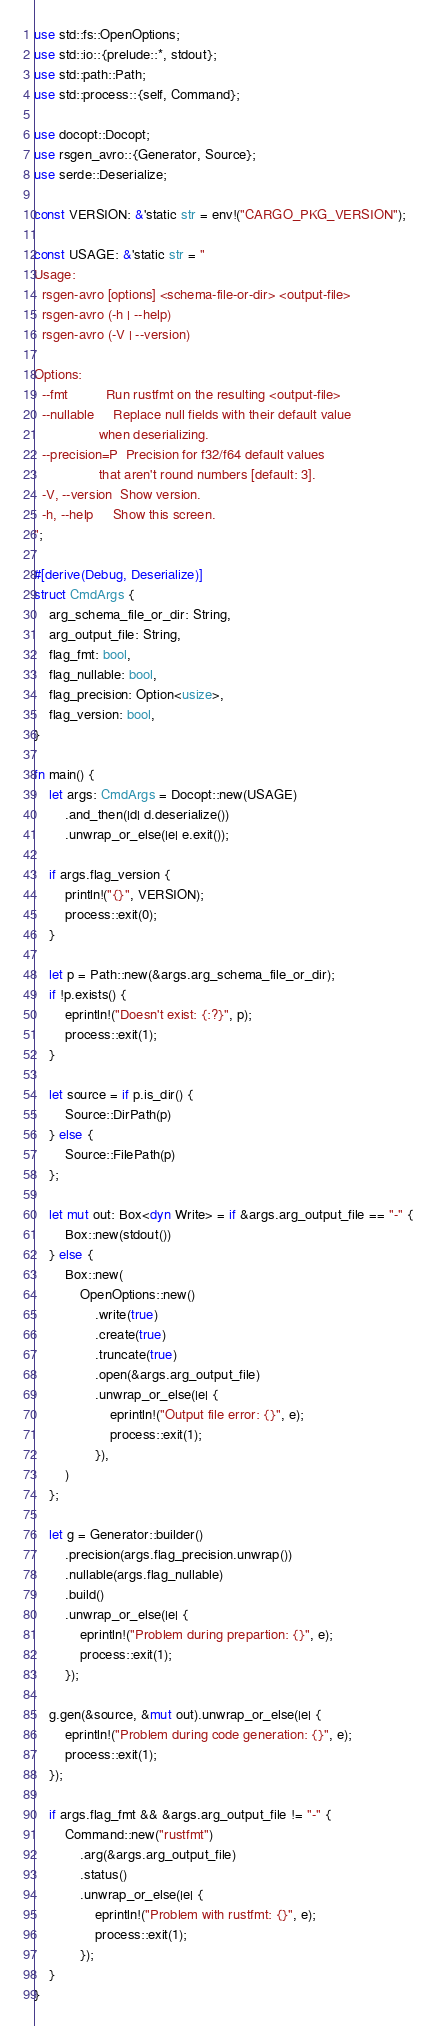<code> <loc_0><loc_0><loc_500><loc_500><_Rust_>use std::fs::OpenOptions;
use std::io::{prelude::*, stdout};
use std::path::Path;
use std::process::{self, Command};

use docopt::Docopt;
use rsgen_avro::{Generator, Source};
use serde::Deserialize;

const VERSION: &'static str = env!("CARGO_PKG_VERSION");

const USAGE: &'static str = "
Usage:
  rsgen-avro [options] <schema-file-or-dir> <output-file>
  rsgen-avro (-h | --help)
  rsgen-avro (-V | --version)

Options:
  --fmt          Run rustfmt on the resulting <output-file>
  --nullable     Replace null fields with their default value
                 when deserializing.
  --precision=P  Precision for f32/f64 default values
                 that aren't round numbers [default: 3].
  -V, --version  Show version.
  -h, --help     Show this screen.
";

#[derive(Debug, Deserialize)]
struct CmdArgs {
    arg_schema_file_or_dir: String,
    arg_output_file: String,
    flag_fmt: bool,
    flag_nullable: bool,
    flag_precision: Option<usize>,
    flag_version: bool,
}

fn main() {
    let args: CmdArgs = Docopt::new(USAGE)
        .and_then(|d| d.deserialize())
        .unwrap_or_else(|e| e.exit());

    if args.flag_version {
        println!("{}", VERSION);
        process::exit(0);
    }

    let p = Path::new(&args.arg_schema_file_or_dir);
    if !p.exists() {
        eprintln!("Doesn't exist: {:?}", p);
        process::exit(1);
    }

    let source = if p.is_dir() {
        Source::DirPath(p)
    } else {
        Source::FilePath(p)
    };

    let mut out: Box<dyn Write> = if &args.arg_output_file == "-" {
        Box::new(stdout())
    } else {
        Box::new(
            OpenOptions::new()
                .write(true)
                .create(true)
                .truncate(true)
                .open(&args.arg_output_file)
                .unwrap_or_else(|e| {
                    eprintln!("Output file error: {}", e);
                    process::exit(1);
                }),
        )
    };

    let g = Generator::builder()
        .precision(args.flag_precision.unwrap())
        .nullable(args.flag_nullable)
        .build()
        .unwrap_or_else(|e| {
            eprintln!("Problem during prepartion: {}", e);
            process::exit(1);
        });

    g.gen(&source, &mut out).unwrap_or_else(|e| {
        eprintln!("Problem during code generation: {}", e);
        process::exit(1);
    });

    if args.flag_fmt && &args.arg_output_file != "-" {
        Command::new("rustfmt")
            .arg(&args.arg_output_file)
            .status()
            .unwrap_or_else(|e| {
                eprintln!("Problem with rustfmt: {}", e);
                process::exit(1);
            });
    }
}
</code> 